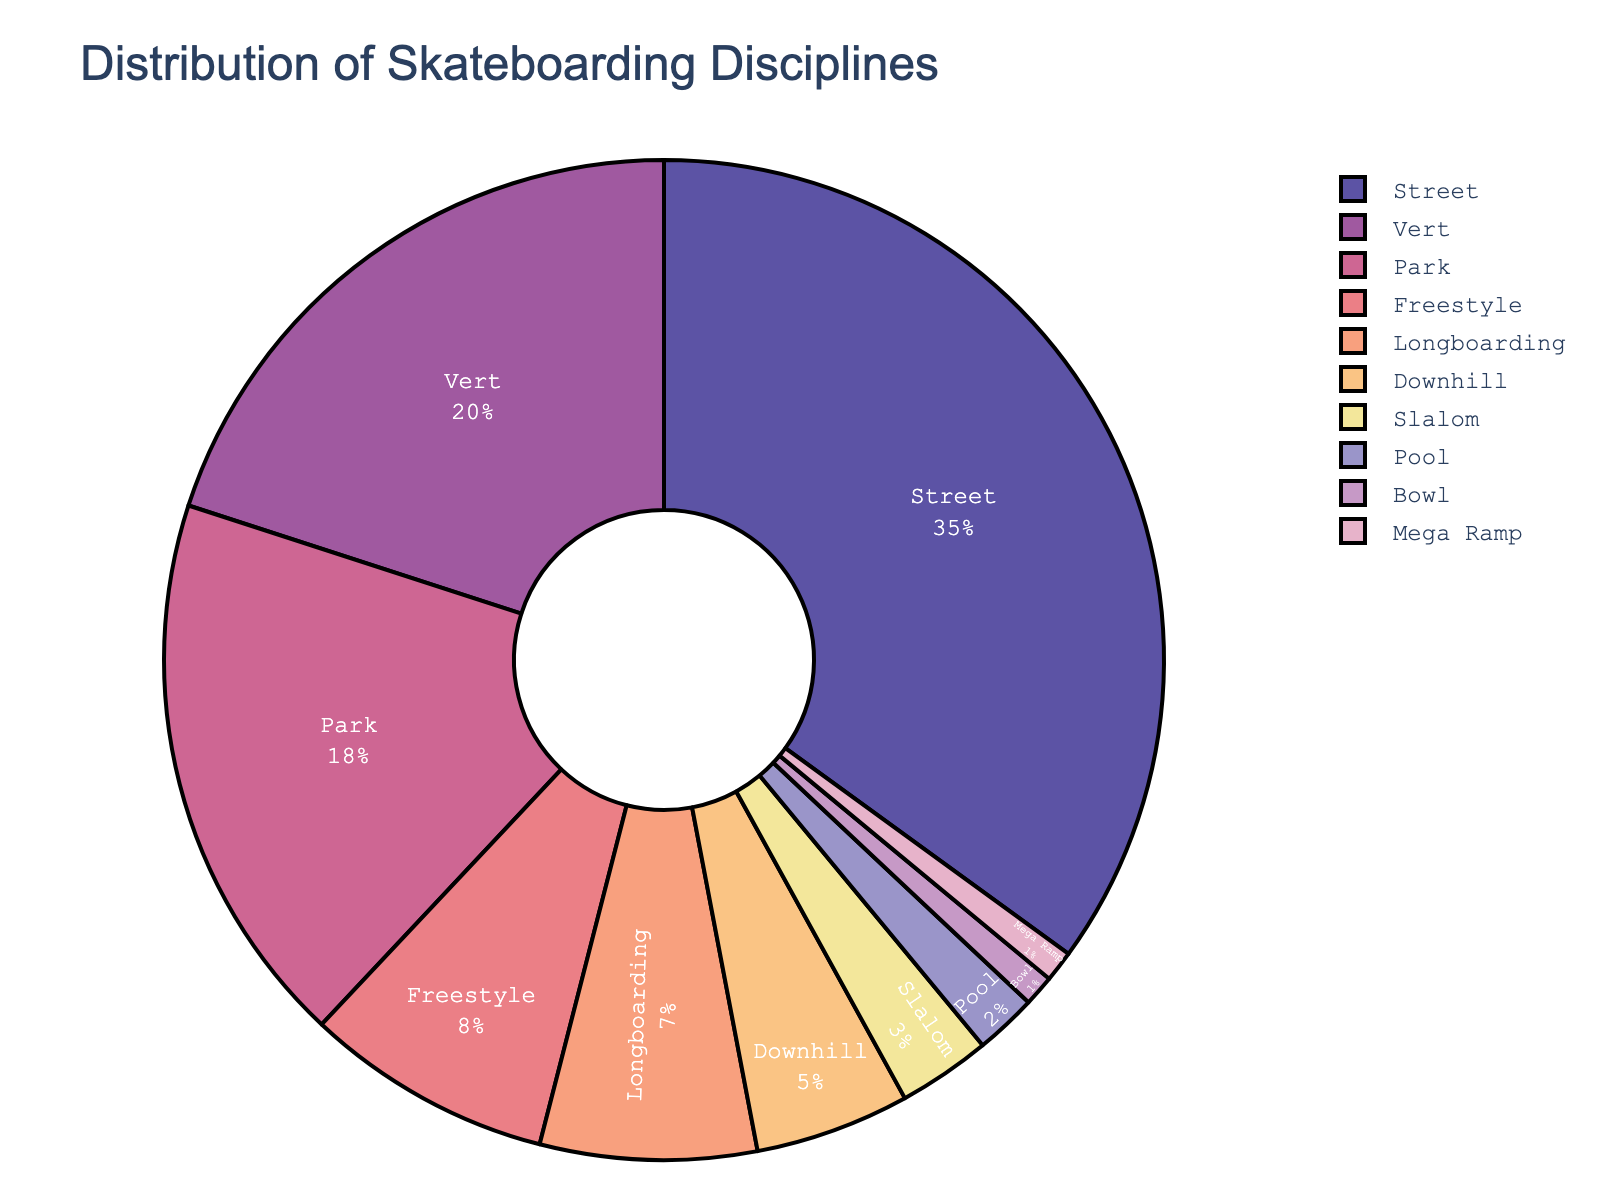Which discipline has the highest representation in the pie chart? The largest portion of the pie chart corresponds to the discipline "Street," indicated by both the size of the segment and its label denoting 35%.
Answer: Street What's the combined percentage of disciplines with less than 10% representation individually? To find this, sum the percentages of Freestyle (8%), Longboarding (7%), Downhill (5%), Slalom (3%), Pool (2%), and Bowl (1%), and Mega Ramp (1%). 8 + 7 + 5 + 3 + 2 + 1 + 1 = 27%.
Answer: 27% How much greater is the percentage of Street compared to Vert? The percentage of Street is 35%, and the percentage of Vert is 20%. The difference is 35 - 20, which equals 15%.
Answer: 15% Which disciplines have the same percentage in the distribution? By looking at the pie chart, both Bowl and Mega Ramp are represented with the same percentage of 1% each.
Answer: Bowl and Mega Ramp If you combine Park and Freestyle, what percentage of the total do they make up? Adding the percentages of Park (18%) and Freestyle (8%) gives us 18 + 8 = 26%.
Answer: 26% What is the average percentage of all listed disciplines? The total percentage of all disciplines combined is 100%, and there are 10 disciplines. So, the average is 100/10 = 10%.
Answer: 10% Which discipline represents the smallest portion on the pie chart? The smallest segment in the pie chart corresponds to Bowl and Mega Ramp, each with 1%.
Answer: Bowl and Mega Ramp What is the difference in percentage between Park and Longboarding? The percentage for Park is 18% and for Longboarding is 7%. The difference is 18 - 7 = 11%.
Answer: 11% What percentage is represented by both Vert and Downhill combined? Adding the percentages of Vert (20%) and Downhill (5%) gives us 20 + 5 = 25%.
Answer: 25% How does the percentage of Slalom compare to that of Pool? The percentage of Slalom is 3%, while the percentage for Pool is 2%. Slalom has a higher percentage by 3 - 2 = 1%.
Answer: Slalom has 1% more than Pool 